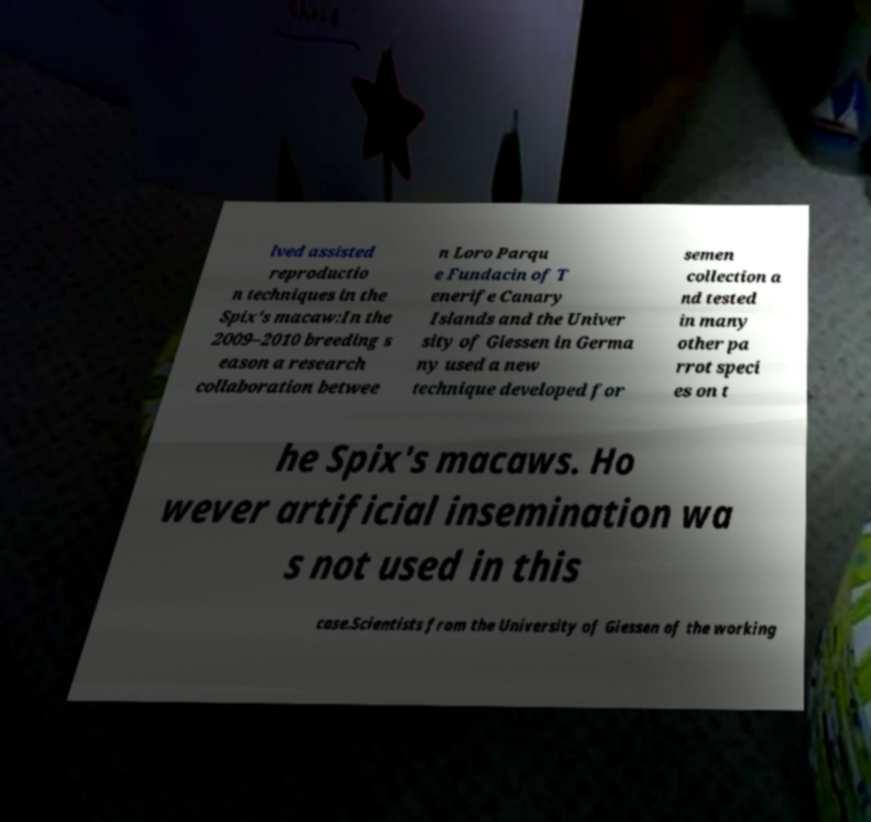Please identify and transcribe the text found in this image. lved assisted reproductio n techniques in the Spix's macaw:In the 2009–2010 breeding s eason a research collaboration betwee n Loro Parqu e Fundacin of T enerife Canary Islands and the Univer sity of Giessen in Germa ny used a new technique developed for semen collection a nd tested in many other pa rrot speci es on t he Spix's macaws. Ho wever artificial insemination wa s not used in this case.Scientists from the University of Giessen of the working 